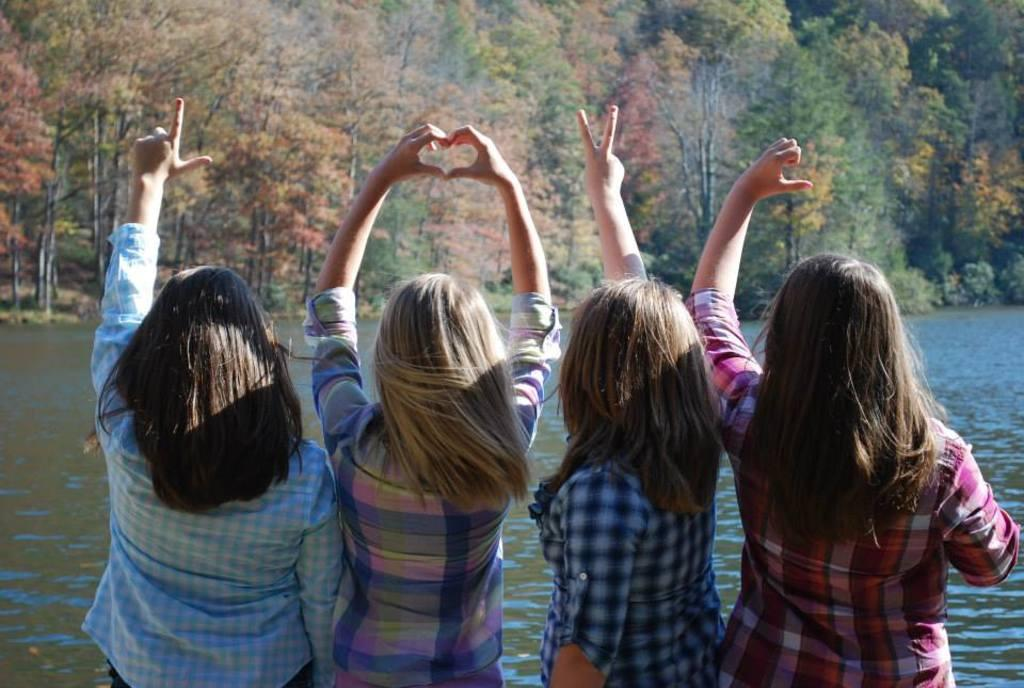How many people are present in the image? There are four people in the image. What can be observed about the clothing of the people in the image? The people are wearing different color dresses. What is visible in the background of the image? There is water and many trees in the background of the image. What type of detail can be seen on the front of the cub in the image? There is no cub present in the image, so it is not possible to answer that question. 